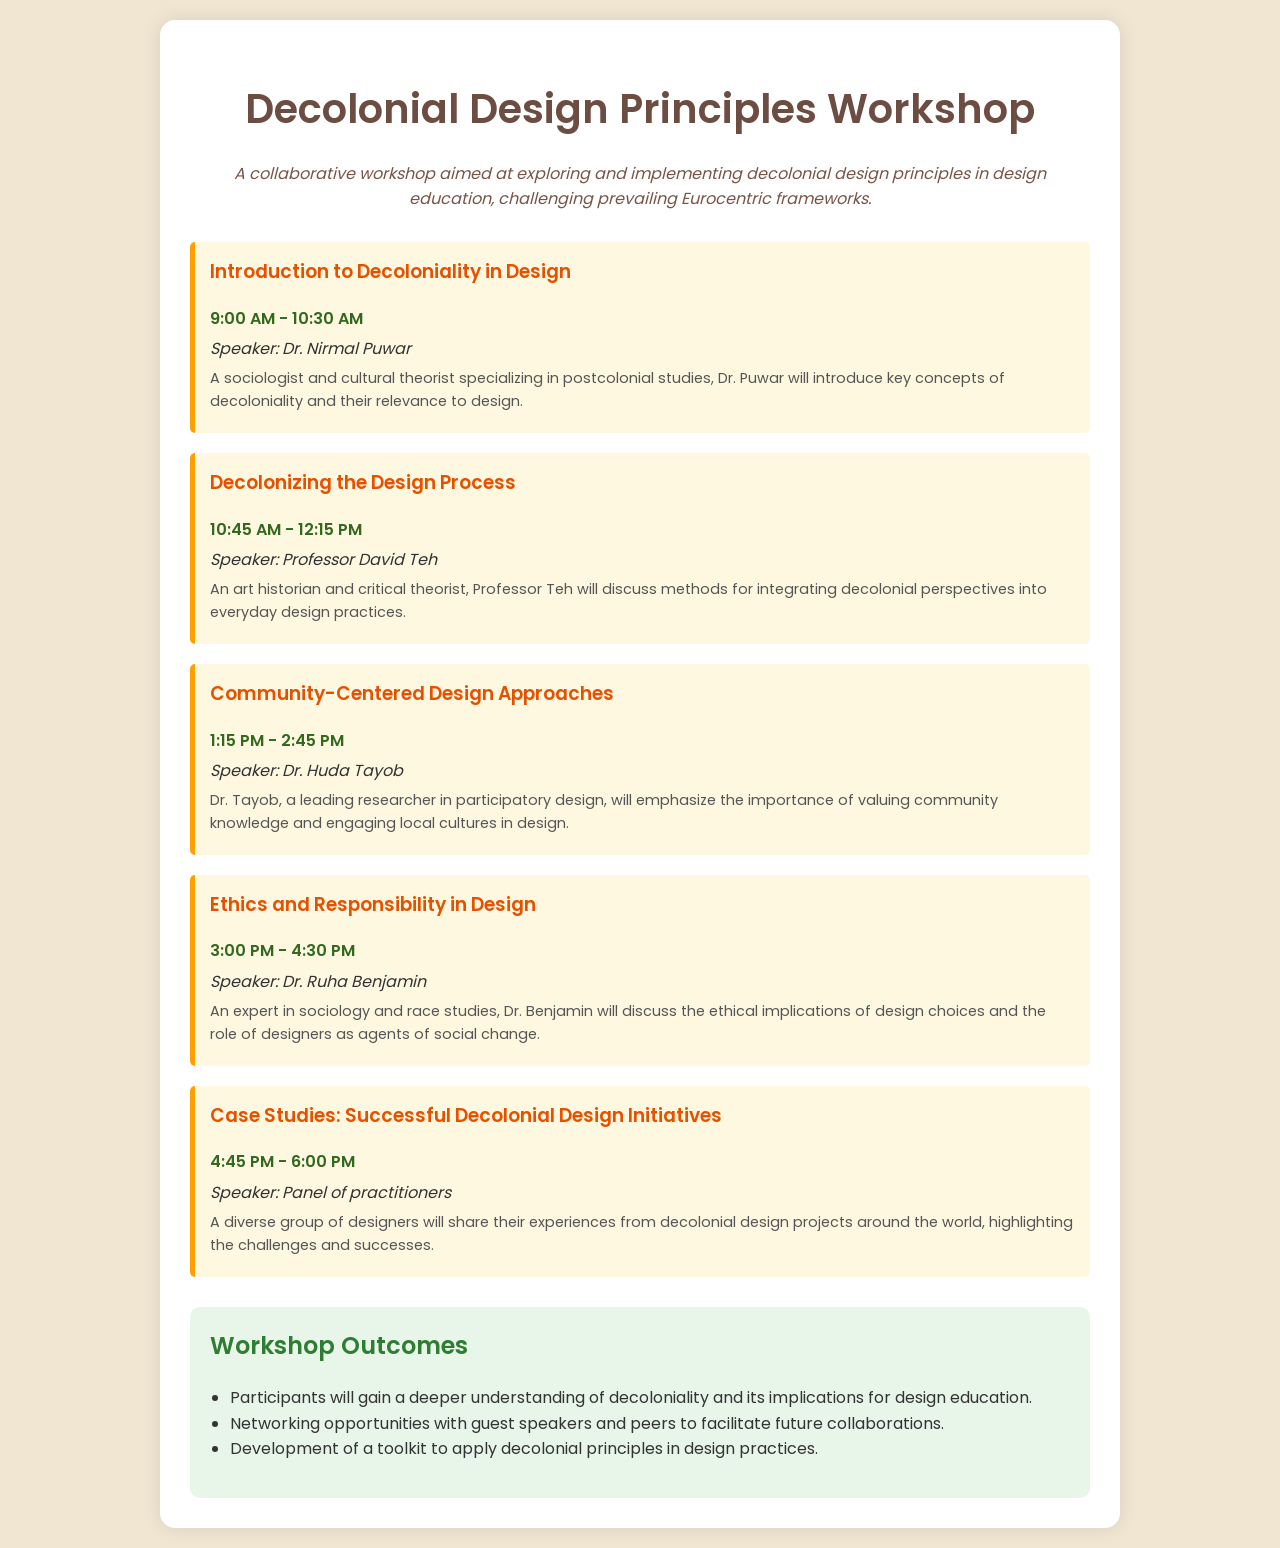What time does the workshop start? The workshop starts at 9:00 AM, as indicated in the schedule.
Answer: 9:00 AM Who is the speaker for the session on "Community-Centered Design Approaches"? The speaker for that session is Dr. Huda Tayob, mentioned in the schedule.
Answer: Dr. Huda Tayob What is the focus of the final session titled "Case Studies: Successful Decolonial Design Initiatives"? The final session focuses on sharing experiences from decolonial design projects, as described in the document.
Answer: Sharing experiences What is the duration of the session titled "Ethics and Responsibility in Design"? The duration can be calculated by subtracting the start time from the end time, 4:30 PM - 3:00 PM is 1.5 hours long.
Answer: 1.5 hours What specific aspect of design does Dr. Ruha Benjamin address in her session? Dr. Ruha Benjamin addresses the ethical implications of design choices in her session.
Answer: Ethical implications How many sessions are scheduled before the lunch break? There are two sessions scheduled before the lunch break, as the break is after the second session.
Answer: Two sessions What is a key outcome participants will gain from this workshop? One key outcome mentioned is a deeper understanding of decoloniality and its implications for design education.
Answer: Deeper understanding Who is a leading researcher in participatory design at this workshop? Dr. Huda Tayob is identified as a leading researcher in participatory design in the document.
Answer: Dr. Huda Tayob 